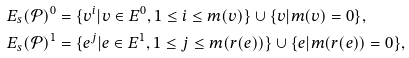<formula> <loc_0><loc_0><loc_500><loc_500>E _ { s } ( \mathcal { P } ) ^ { 0 } & = \{ v ^ { i } | v \in E ^ { 0 } , 1 \leq i \leq m ( v ) \} \cup \{ v | m ( v ) = 0 \} , \\ E _ { s } ( \mathcal { P } ) ^ { 1 } & = \{ e ^ { j } | e \in E ^ { 1 } , 1 \leq j \leq m ( r ( e ) ) \} \cup \{ e | m ( r ( e ) ) = 0 \} ,</formula> 